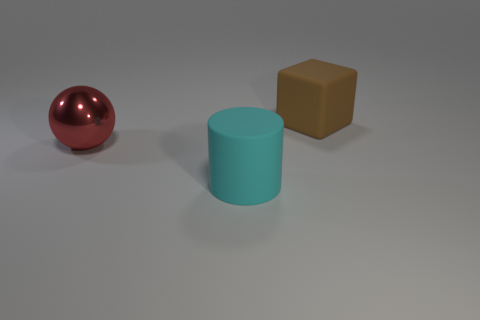Add 3 rubber cubes. How many objects exist? 6 Subtract all spheres. How many objects are left? 2 Subtract all brown matte cubes. Subtract all large cyan matte cylinders. How many objects are left? 1 Add 2 large cylinders. How many large cylinders are left? 3 Add 1 cyan objects. How many cyan objects exist? 2 Subtract 0 purple cylinders. How many objects are left? 3 